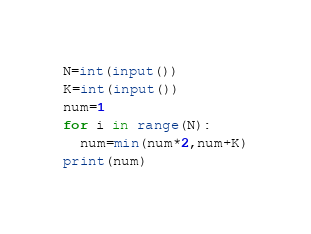Convert code to text. <code><loc_0><loc_0><loc_500><loc_500><_Python_>N=int(input())
K=int(input())
num=1
for i in range(N):
  num=min(num*2,num+K)
print(num) </code> 